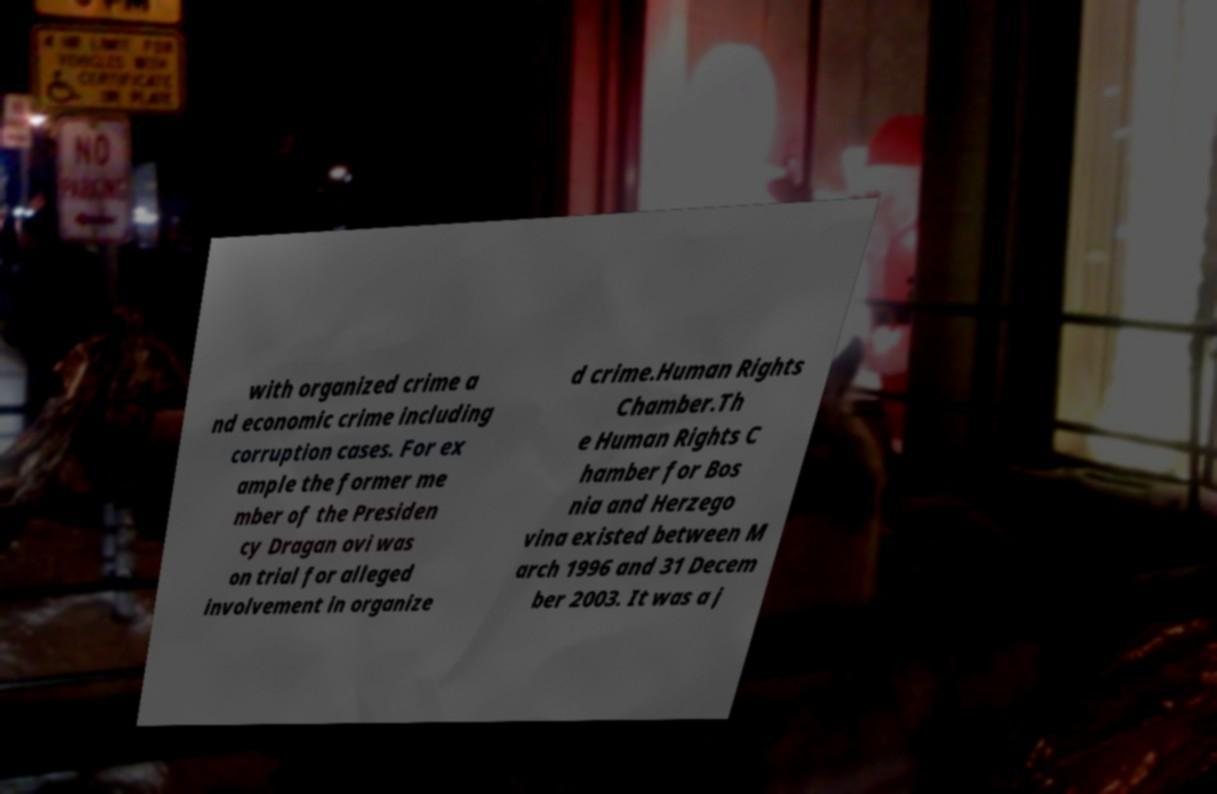What messages or text are displayed in this image? I need them in a readable, typed format. with organized crime a nd economic crime including corruption cases. For ex ample the former me mber of the Presiden cy Dragan ovi was on trial for alleged involvement in organize d crime.Human Rights Chamber.Th e Human Rights C hamber for Bos nia and Herzego vina existed between M arch 1996 and 31 Decem ber 2003. It was a j 